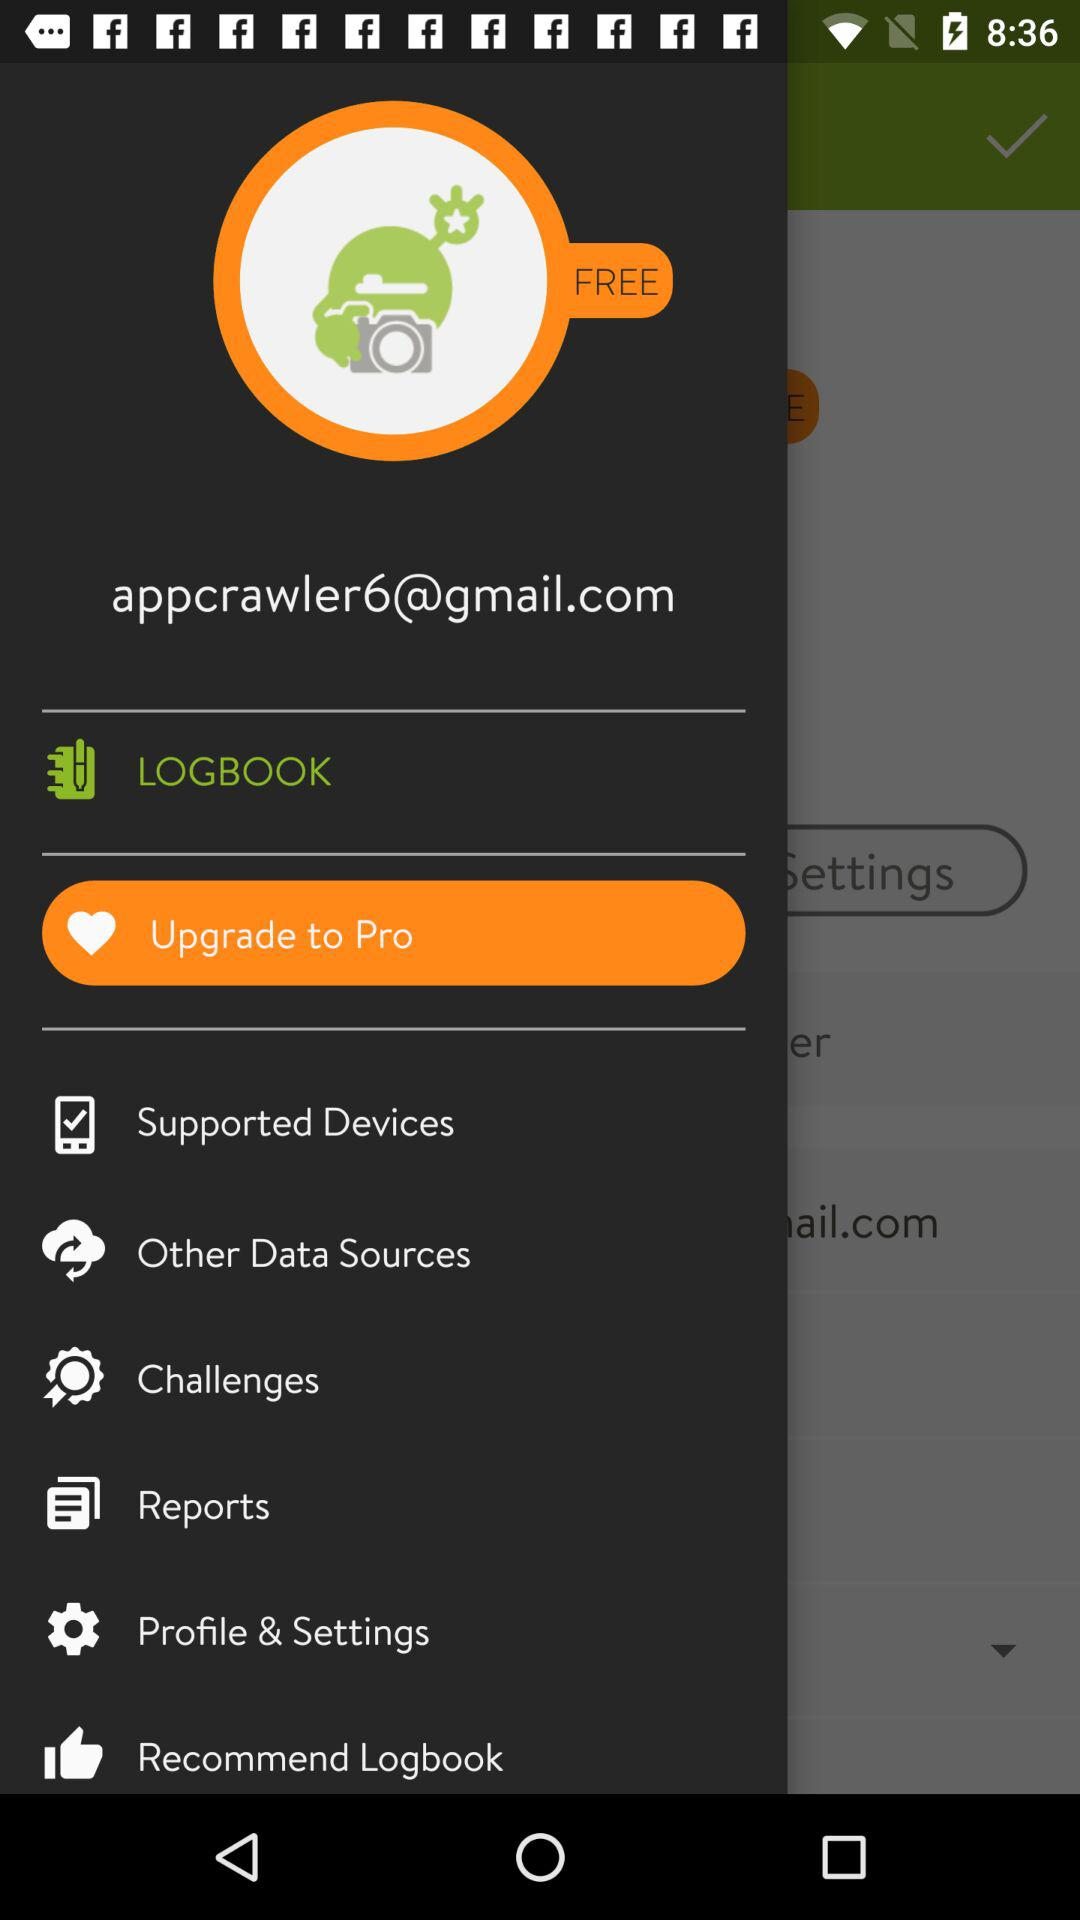What's the Gmail address? The Gmail address is appcrawler6@gmail.com. 